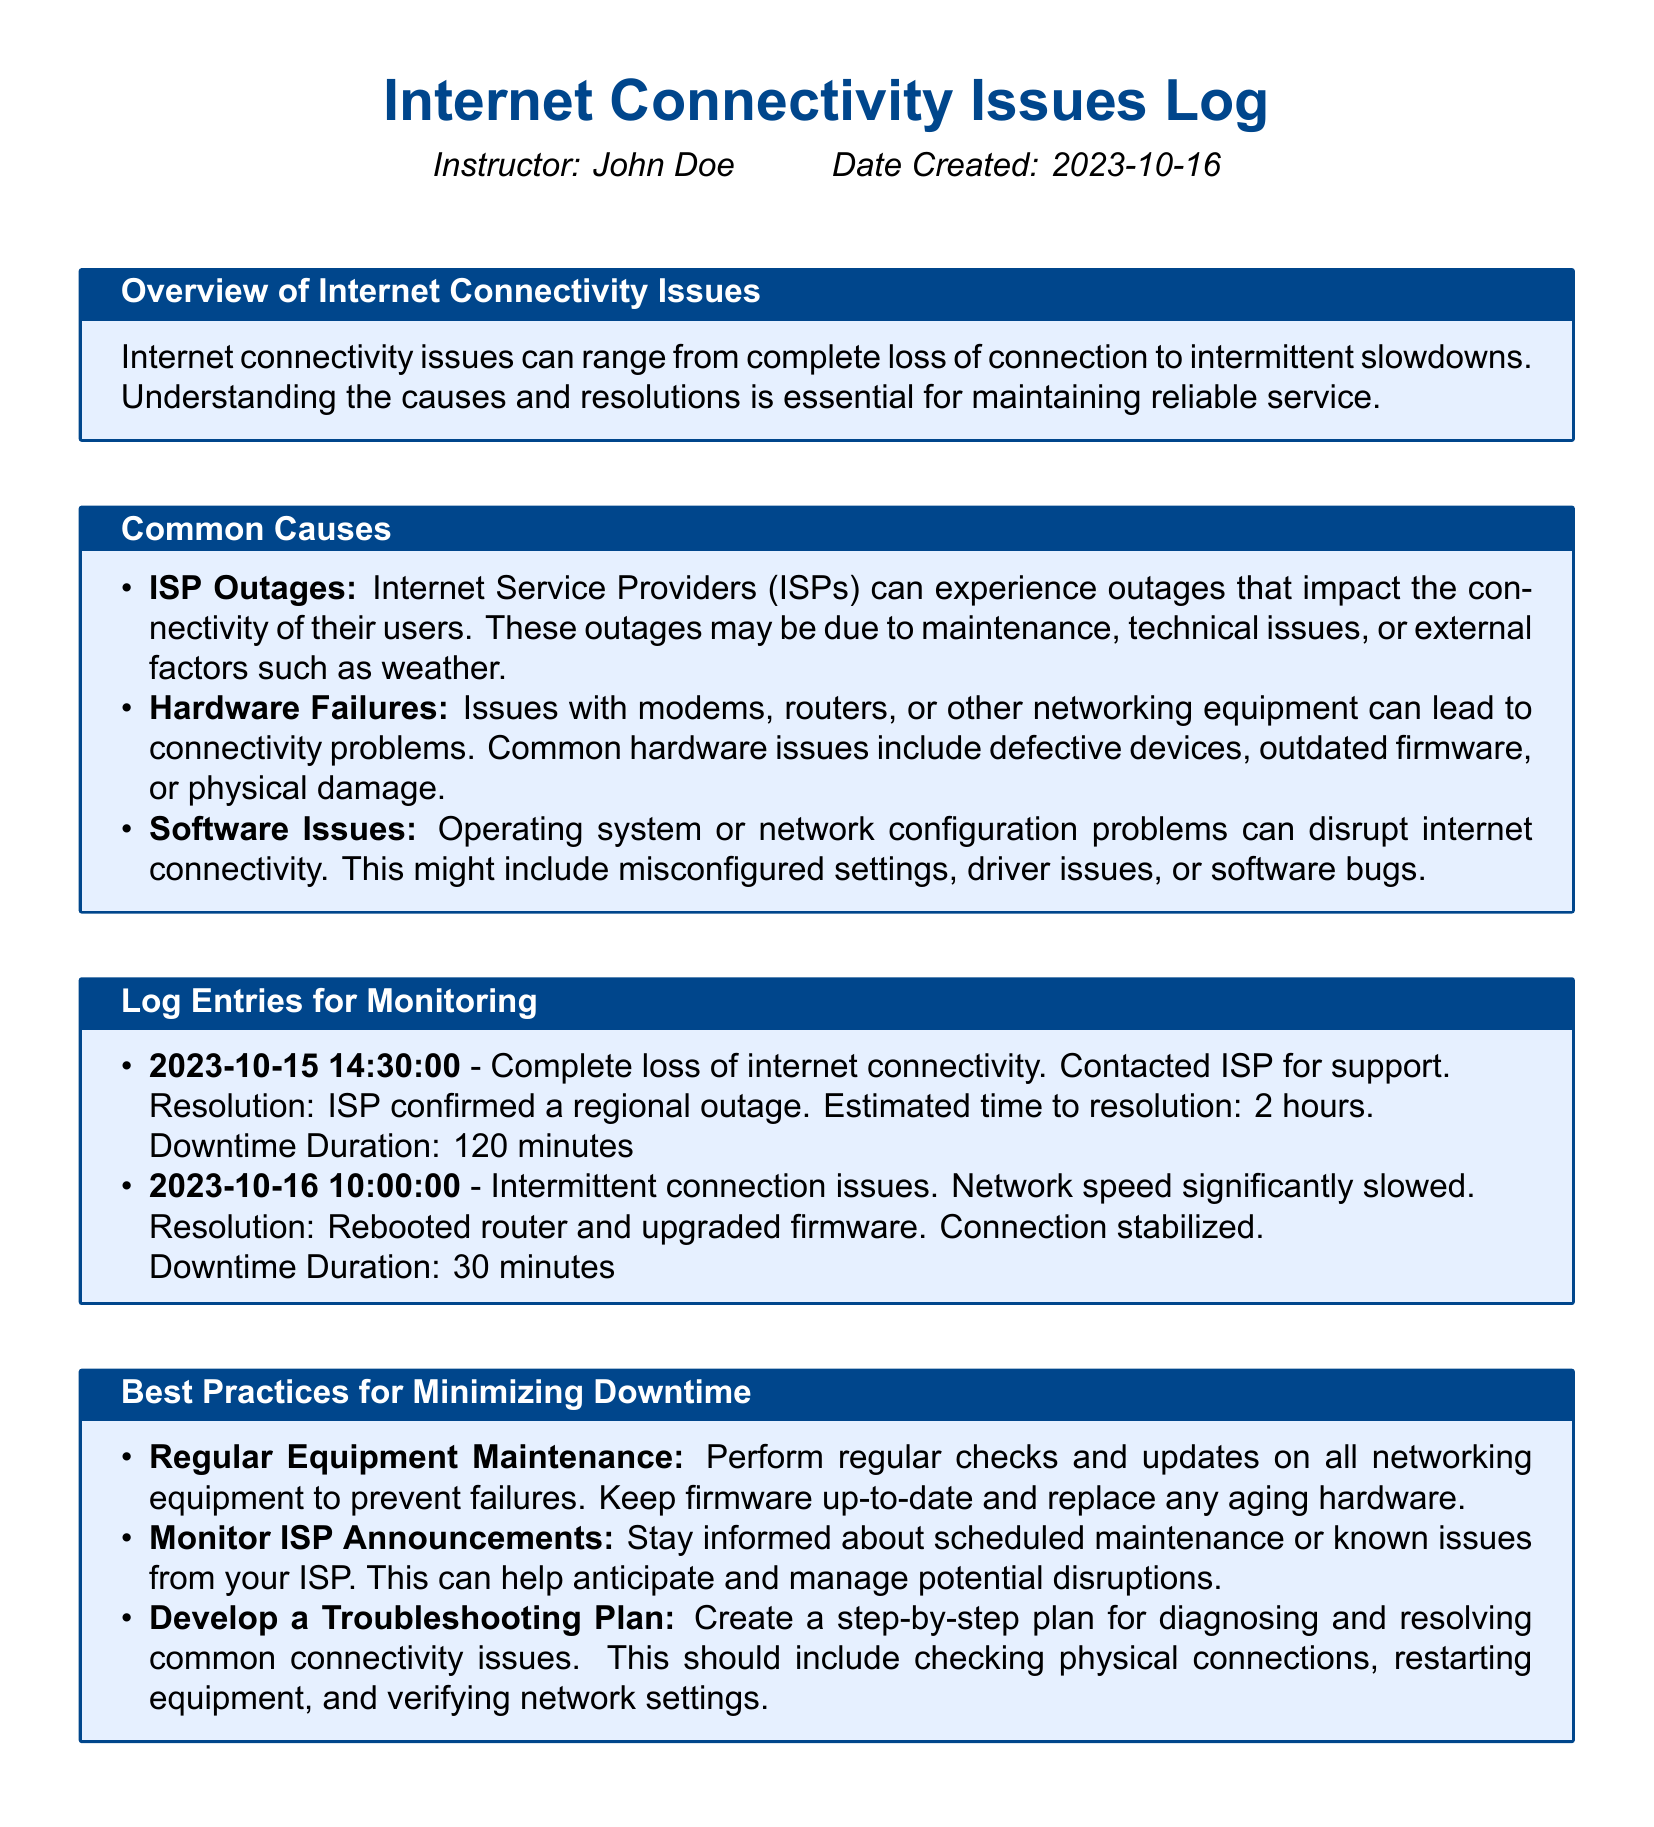What is the title of the document? The title is found at the top of the document and summarizes the content regarding connectivity issues.
Answer: Internet Connectivity Issues Log Who is the instructor of the document? The instructor's name is specifically mentioned in the introductory section of the document.
Answer: John Doe What is the downtime duration for the first log entry? The downtime duration for the first entry is stated clearly in the resolution section of that entry.
Answer: 120 minutes When was the document created? The creation date can be found in the introductory section, specifying when the document was logged.
Answer: 2023-10-16 What was the resolution for the intermittent connection issues? The resolution for the intermittent issues is mentioned in the description of the second log entry.
Answer: Rebooted router and upgraded firmware How many log entries are present in the document? The number of log entries can be counted from the list under the "Log Entries for Monitoring" section.
Answer: 2 What type of issues can ISP outages cause? The overview section explains the impact ISP outages have on connectivity.
Answer: Complete loss of connection What is a best practice for minimizing downtime? Best practices are outlined in the designated section, focusing on effective strategies.
Answer: Regular Equipment Maintenance 